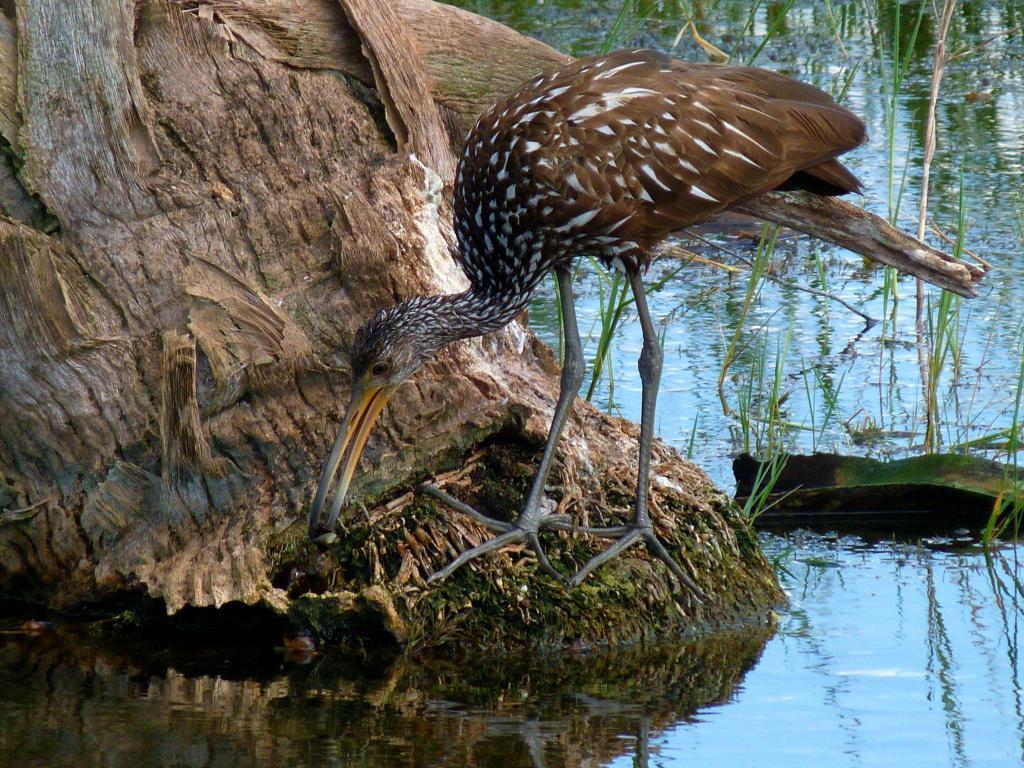Please provide a concise description of this image. In the middle of the picture, we see a bird which looks like a crane and it is named as Limpkin. Beside that, we see the stem of the tree. At the bottom of the picture, we see water and we even see the grass. This picture might be clicked in a zoo. 